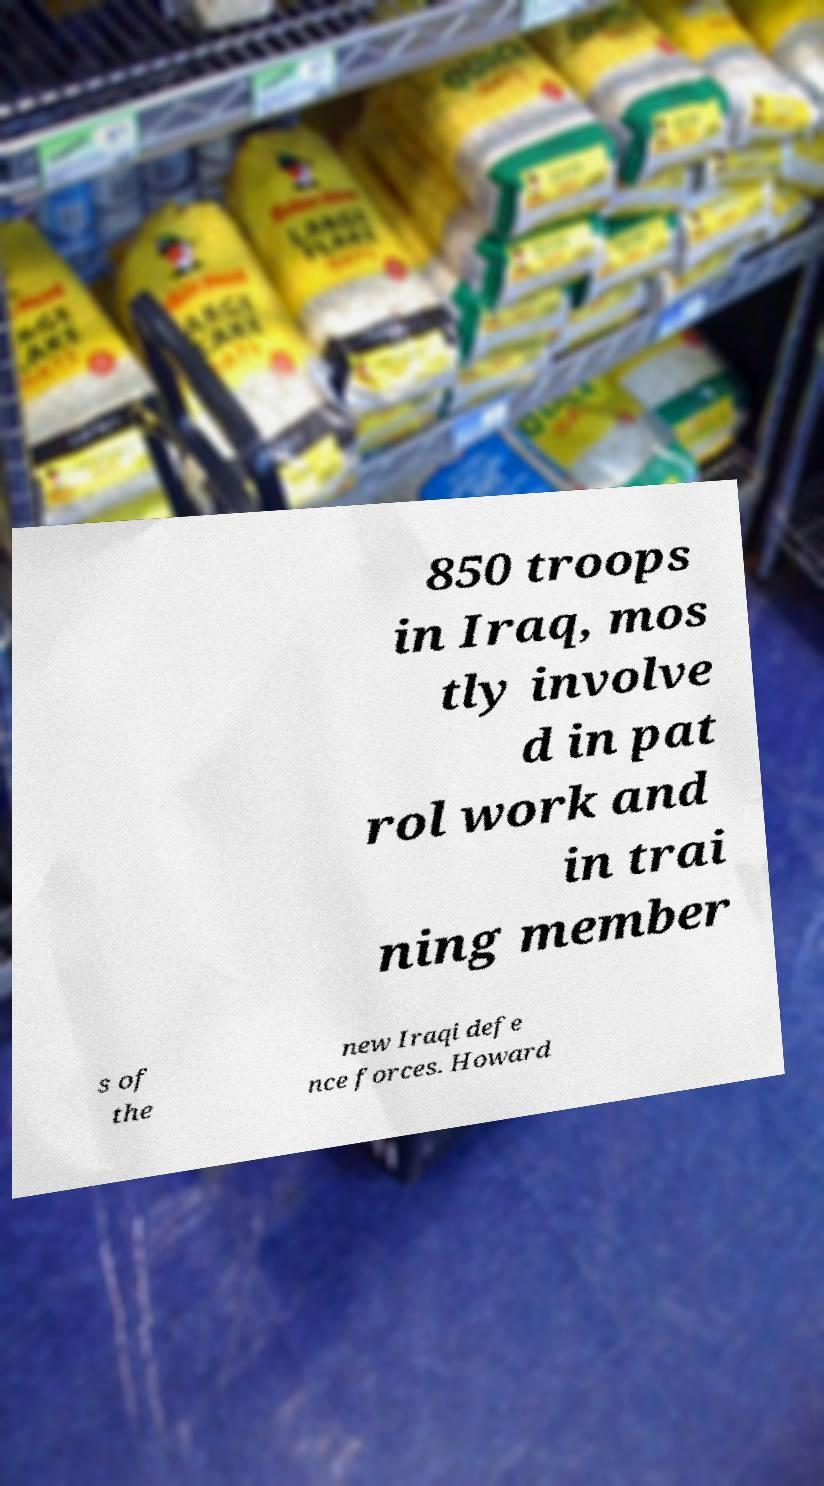Could you extract and type out the text from this image? 850 troops in Iraq, mos tly involve d in pat rol work and in trai ning member s of the new Iraqi defe nce forces. Howard 